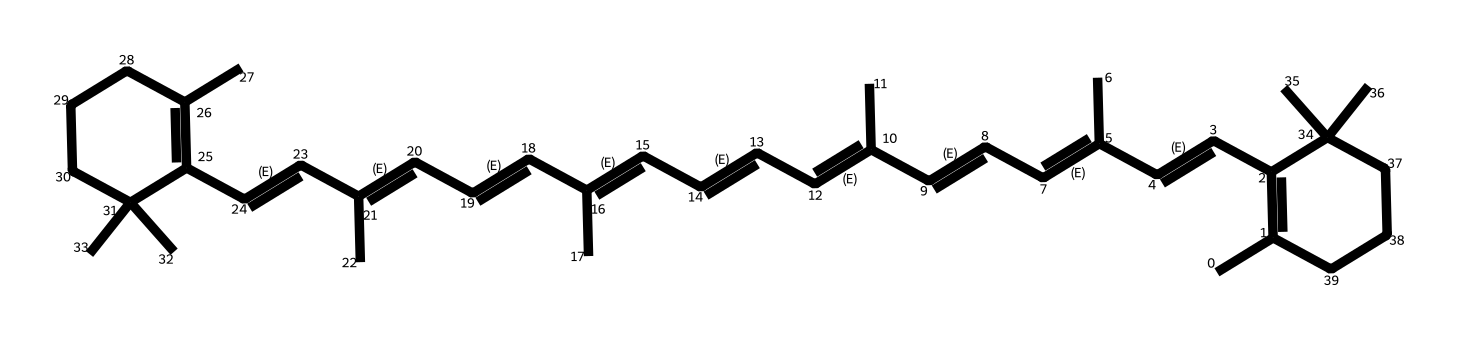What is the molecular formula of the compound? To determine the molecular formula, we need to count all the carbon (C), hydrogen (H), and any other atoms present in the SMILES representation. In this case, counting reveals that there are 40 carbon atoms and 56 hydrogen atoms, resulting in the molecular formula being C40H56.
Answer: C40H56 How many double bonds are present in the molecule? Analyzing the SMILES shows several occurrences of C=C, indicating the presence of double bonds. By counting each C=C, we determine that there are 11 double bonds in total throughout the structure.
Answer: 11 Which type of geometric isomerism can occur in this molecule? This molecule has multiple double bonds in its structure, which allows for cis/trans isomerism. Each double bond can either adopt a cis configuration (same side of the double bond) or a trans configuration (opposite sides), indicating that cis/trans isomerism can occur.
Answer: cis/trans What is the significance of geometric isomerism in carotenoids? Geometric isomerism in carotenoids can affect the pigmentation and absorption spectra of light, influencing their roles in photosynthesis and plant coloration. This diversity can enhance adaptation to different environments.
Answer: pigmentation Identify a common crop that contains carotenoid pigments. One common crop that contains carotenoids is the carrot, which is rich in beta-carotene, a specific type of carotenoid pigment involved in coloration and provitamin A activity.
Answer: carrot 